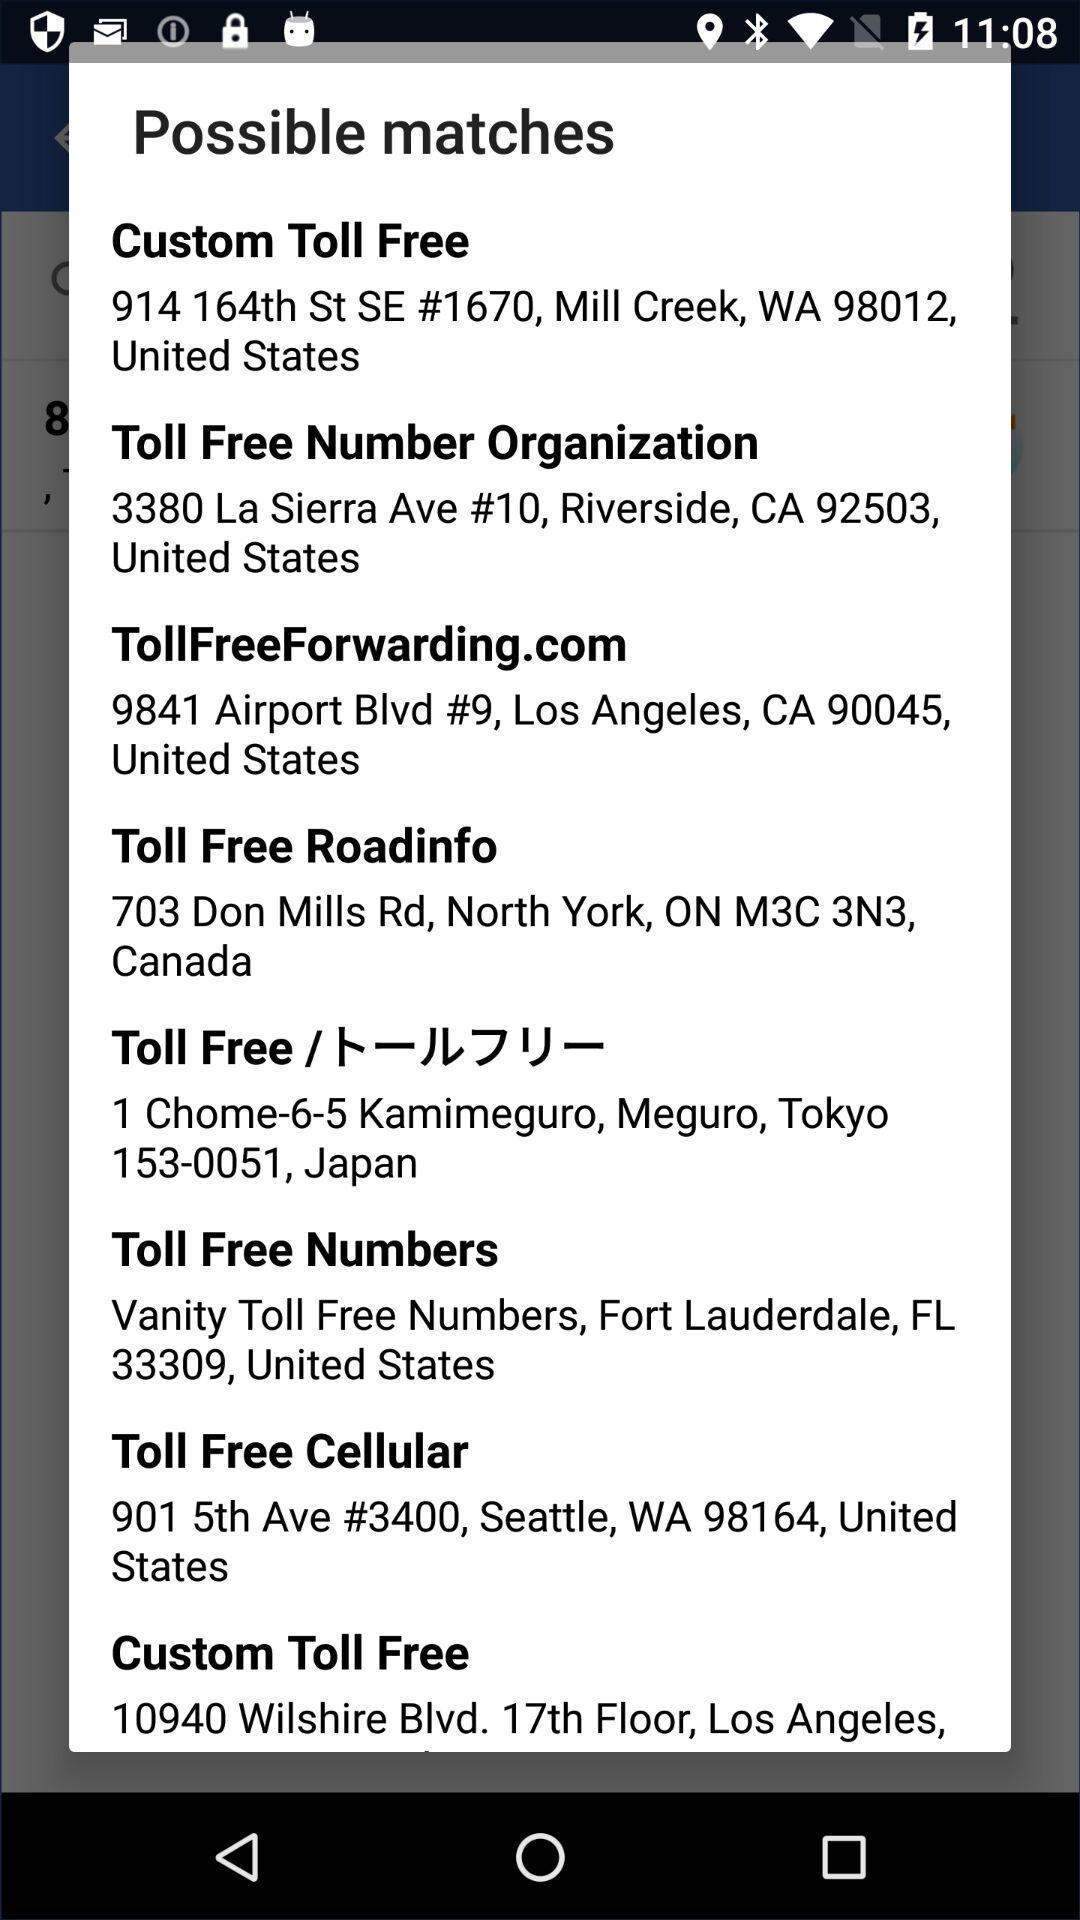What is the address of "Toll Free Number Organization"? The address is "3380 La Sierra Ave #10, Riverside, CA 92503, United States". 